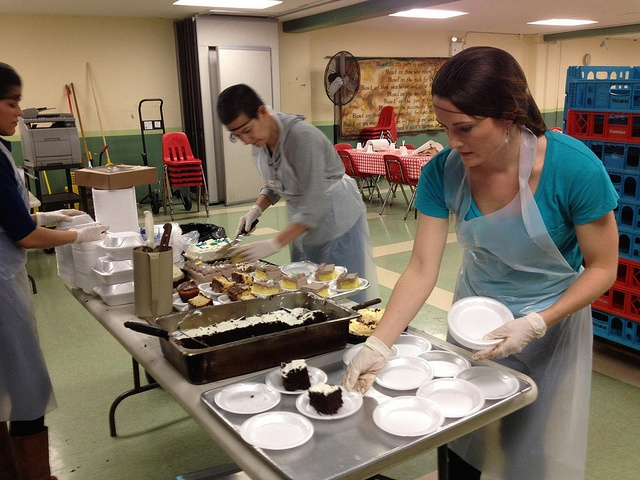Describe the objects in this image and their specific colors. I can see people in gray, black, and teal tones, dining table in gray, white, darkgray, and black tones, people in gray, darkgray, and black tones, people in gray, black, and maroon tones, and dining table in gray and darkgray tones in this image. 